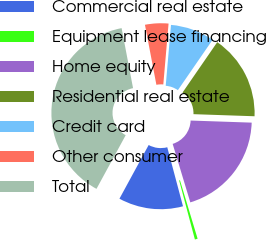Convert chart. <chart><loc_0><loc_0><loc_500><loc_500><pie_chart><fcel>Commercial real estate<fcel>Equipment lease financing<fcel>Home equity<fcel>Residential real estate<fcel>Credit card<fcel>Other consumer<fcel>Total<nl><fcel>12.08%<fcel>0.52%<fcel>19.79%<fcel>15.94%<fcel>8.23%<fcel>4.37%<fcel>39.07%<nl></chart> 